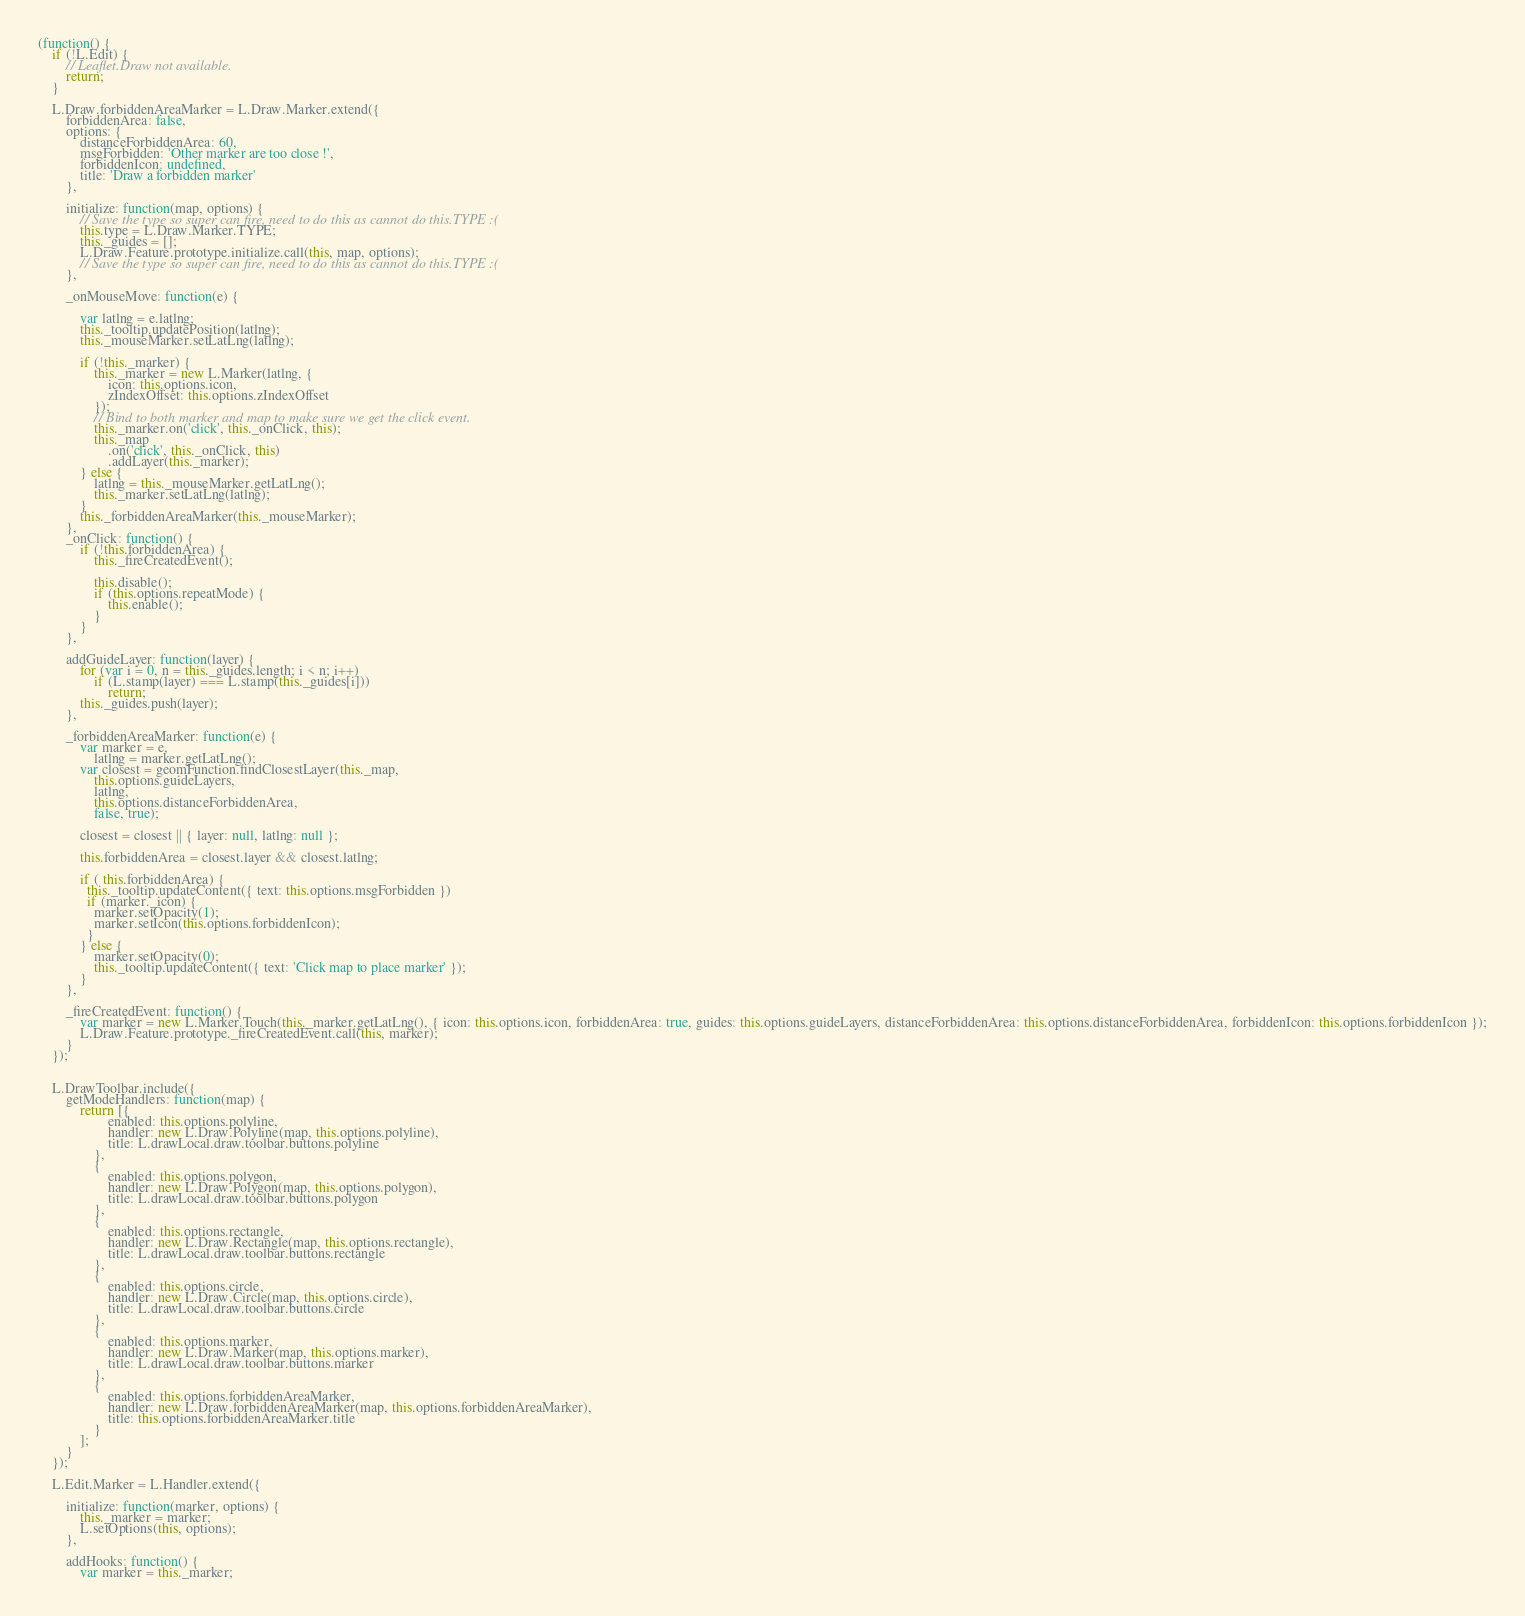<code> <loc_0><loc_0><loc_500><loc_500><_JavaScript_>(function() {
    if (!L.Edit) {
        // Leaflet.Draw not available.
        return;
    }

    L.Draw.forbiddenAreaMarker = L.Draw.Marker.extend({
        forbiddenArea: false,
        options: {
            distanceForbiddenArea: 60,
            msgForbidden: 'Other marker are too close !',
            forbiddenIcon: undefined,
            title: 'Draw a forbidden marker'
        },

        initialize: function(map, options) {
            // Save the type so super can fire, need to do this as cannot do this.TYPE :(
            this.type = L.Draw.Marker.TYPE;
            this._guides = [];
            L.Draw.Feature.prototype.initialize.call(this, map, options);
            // Save the type so super can fire, need to do this as cannot do this.TYPE :(
        },

        _onMouseMove: function(e) {

            var latlng = e.latlng;
            this._tooltip.updatePosition(latlng);
            this._mouseMarker.setLatLng(latlng);

            if (!this._marker) {
                this._marker = new L.Marker(latlng, {
                    icon: this.options.icon,
                    zIndexOffset: this.options.zIndexOffset
                });
                // Bind to both marker and map to make sure we get the click event.
                this._marker.on('click', this._onClick, this);
                this._map
                    .on('click', this._onClick, this)
                    .addLayer(this._marker);
            } else {
                latlng = this._mouseMarker.getLatLng();
                this._marker.setLatLng(latlng);
            }
            this._forbiddenAreaMarker(this._mouseMarker);
        },
        _onClick: function() {
            if (!this.forbiddenArea) {
                this._fireCreatedEvent();

                this.disable();
                if (this.options.repeatMode) {
                    this.enable();
                }
            }
        },

        addGuideLayer: function(layer) {
            for (var i = 0, n = this._guides.length; i < n; i++)
                if (L.stamp(layer) === L.stamp(this._guides[i]))
                    return;
            this._guides.push(layer);
        },

        _forbiddenAreaMarker: function(e) {
            var marker = e,
                latlng = marker.getLatLng();
            var closest = geomFunction.findClosestLayer(this._map,
                this.options.guideLayers,
                latlng,
                this.options.distanceForbiddenArea,
                false, true);

            closest = closest || { layer: null, latlng: null };

            this.forbiddenArea = closest.layer && closest.latlng;

            if ( this.forbiddenArea) {
              this._tooltip.updateContent({ text: this.options.msgForbidden })
              if (marker._icon) {
                marker.setOpacity(1);
                marker.setIcon(this.options.forbiddenIcon);
              }
            } else {
                marker.setOpacity(0);
                this._tooltip.updateContent({ text: 'Click map to place marker' });
            }
        },

        _fireCreatedEvent: function() {
            var marker = new L.Marker.Touch(this._marker.getLatLng(), { icon: this.options.icon, forbiddenArea: true, guides: this.options.guideLayers, distanceForbiddenArea: this.options.distanceForbiddenArea, forbiddenIcon: this.options.forbiddenIcon });
            L.Draw.Feature.prototype._fireCreatedEvent.call(this, marker);
        }
    });


    L.DrawToolbar.include({
        getModeHandlers: function(map) {
            return [{
                    enabled: this.options.polyline,
                    handler: new L.Draw.Polyline(map, this.options.polyline),
                    title: L.drawLocal.draw.toolbar.buttons.polyline
                },
                {
                    enabled: this.options.polygon,
                    handler: new L.Draw.Polygon(map, this.options.polygon),
                    title: L.drawLocal.draw.toolbar.buttons.polygon
                },
                {
                    enabled: this.options.rectangle,
                    handler: new L.Draw.Rectangle(map, this.options.rectangle),
                    title: L.drawLocal.draw.toolbar.buttons.rectangle
                },
                {
                    enabled: this.options.circle,
                    handler: new L.Draw.Circle(map, this.options.circle),
                    title: L.drawLocal.draw.toolbar.buttons.circle
                },
                {
                    enabled: this.options.marker,
                    handler: new L.Draw.Marker(map, this.options.marker),
                    title: L.drawLocal.draw.toolbar.buttons.marker
                },
                {
                    enabled: this.options.forbiddenAreaMarker,
                    handler: new L.Draw.forbiddenAreaMarker(map, this.options.forbiddenAreaMarker),
                    title: this.options.forbiddenAreaMarker.title
                }
            ];
        }
    });

    L.Edit.Marker = L.Handler.extend({

        initialize: function(marker, options) {
            this._marker = marker;
            L.setOptions(this, options);
        },

        addHooks: function() {
            var marker = this._marker;
</code> 